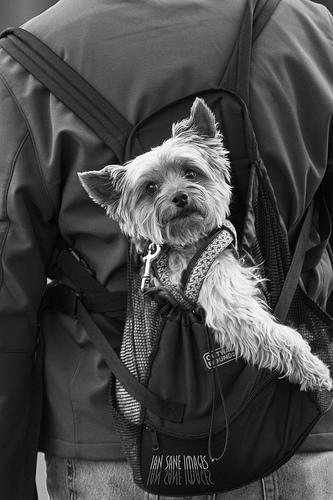How many dogs are there?
Give a very brief answer. 1. 